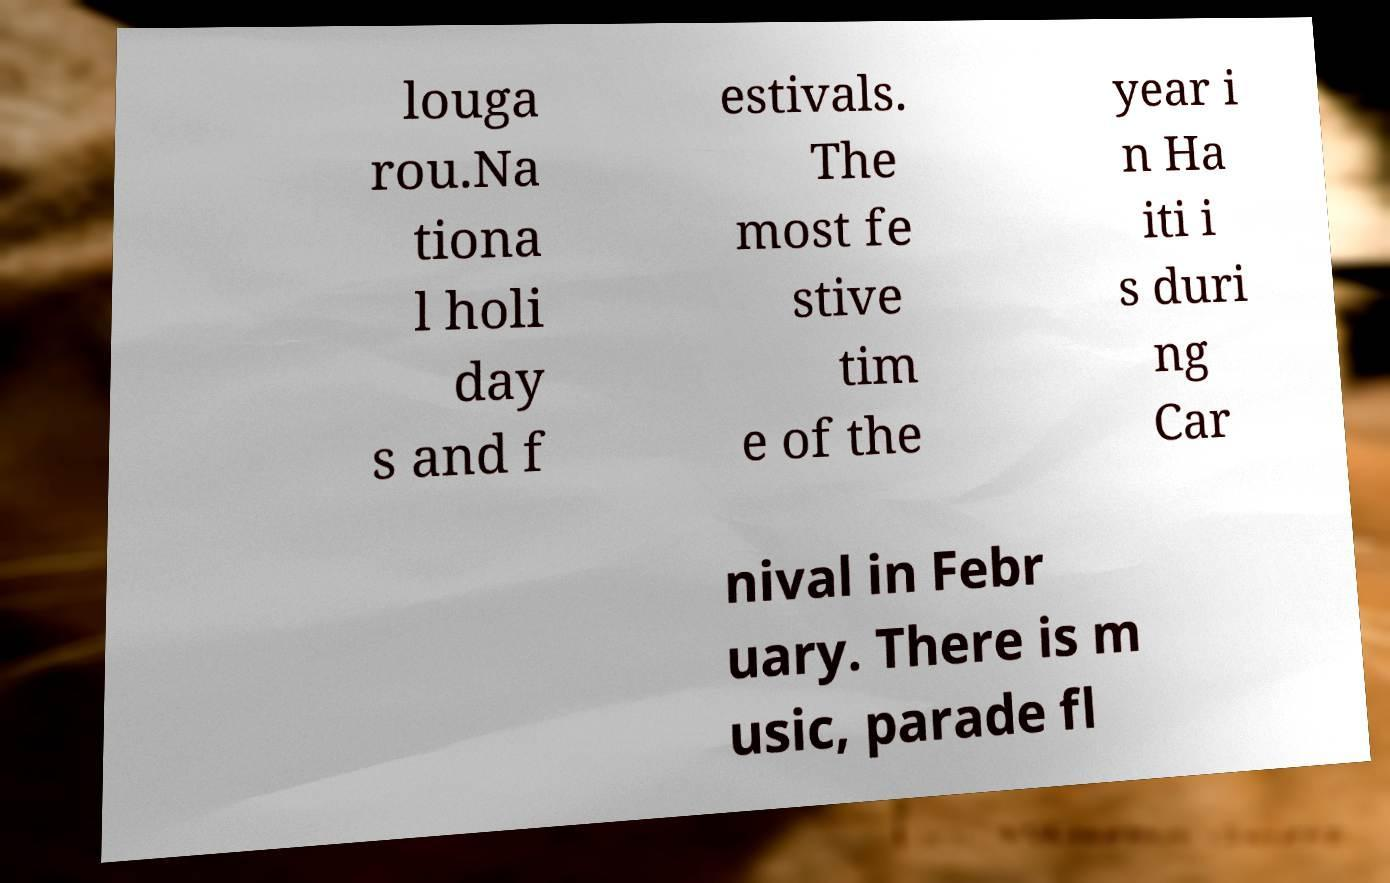Could you extract and type out the text from this image? louga rou.Na tiona l holi day s and f estivals. The most fe stive tim e of the year i n Ha iti i s duri ng Car nival in Febr uary. There is m usic, parade fl 